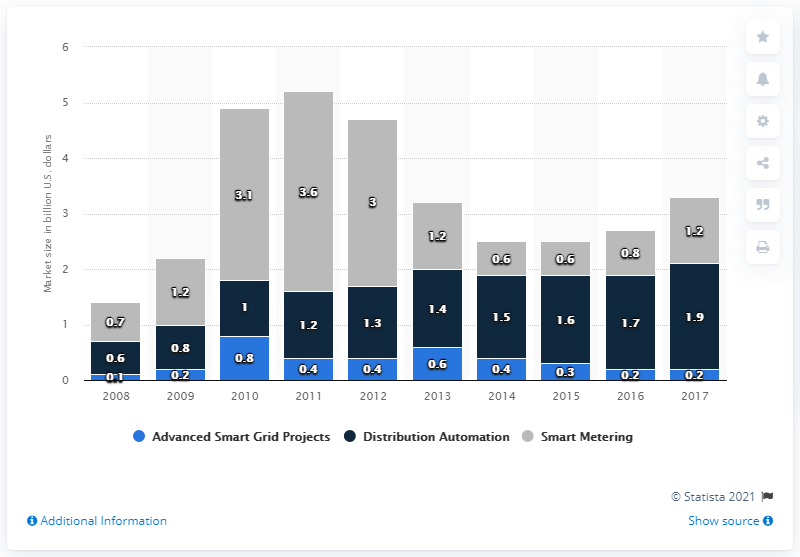Specify some key components in this picture. According to estimates, the value of U.S. smart grid spending within the smart metering segment in 2017 was approximately 1.2 billion dollars. 